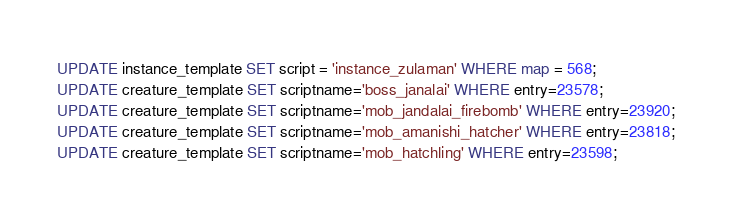Convert code to text. <code><loc_0><loc_0><loc_500><loc_500><_SQL_>UPDATE instance_template SET script = 'instance_zulaman' WHERE map = 568;
UPDATE creature_template SET scriptname='boss_janalai' WHERE entry=23578;
UPDATE creature_template SET scriptname='mob_jandalai_firebomb' WHERE entry=23920;
UPDATE creature_template SET scriptname='mob_amanishi_hatcher' WHERE entry=23818;
UPDATE creature_template SET scriptname='mob_hatchling' WHERE entry=23598;
</code> 